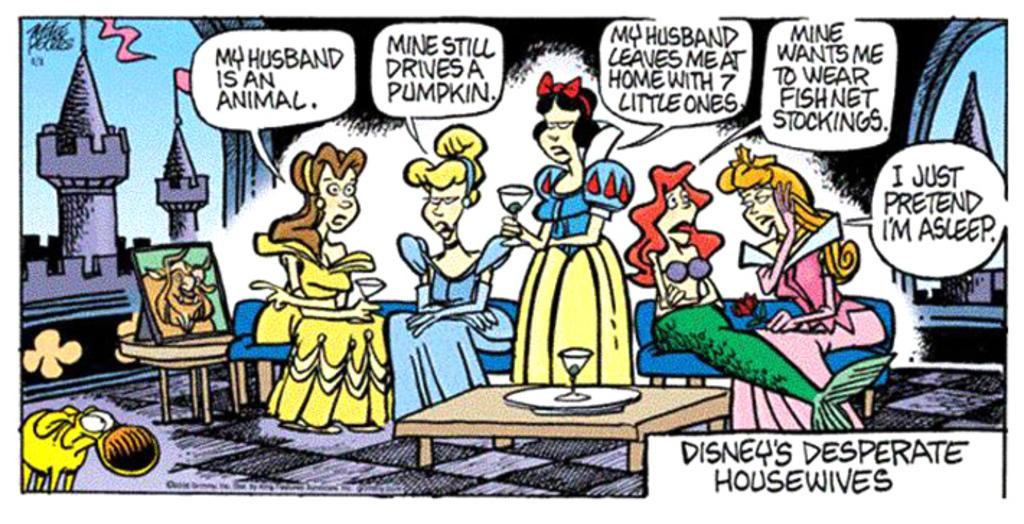What are the people in the image doing? There are persons sitting in the image. What else can be seen in the image besides the people? There are texts and a building visible in the image. What type of furniture is present in the image? There is a table in the image. What is placed on the table in the image? There is a glass on the table in the image. What type of trousers is the sign wearing in the image? There is no sign or trousers present in the image. How do the people in the image react to the unexpected event? There is no unexpected event mentioned in the image, so it is not possible to determine how the people might react. 